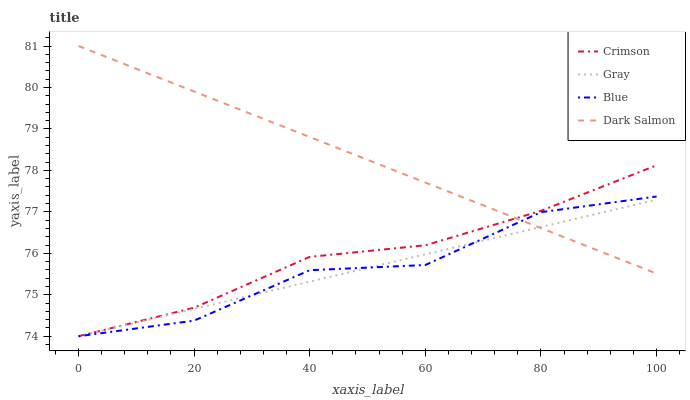Does Gray have the minimum area under the curve?
Answer yes or no. Yes. Does Dark Salmon have the maximum area under the curve?
Answer yes or no. Yes. Does Dark Salmon have the minimum area under the curve?
Answer yes or no. No. Does Gray have the maximum area under the curve?
Answer yes or no. No. Is Dark Salmon the smoothest?
Answer yes or no. Yes. Is Blue the roughest?
Answer yes or no. Yes. Is Gray the smoothest?
Answer yes or no. No. Is Gray the roughest?
Answer yes or no. No. Does Crimson have the lowest value?
Answer yes or no. Yes. Does Dark Salmon have the lowest value?
Answer yes or no. No. Does Dark Salmon have the highest value?
Answer yes or no. Yes. Does Gray have the highest value?
Answer yes or no. No. Does Dark Salmon intersect Crimson?
Answer yes or no. Yes. Is Dark Salmon less than Crimson?
Answer yes or no. No. Is Dark Salmon greater than Crimson?
Answer yes or no. No. 